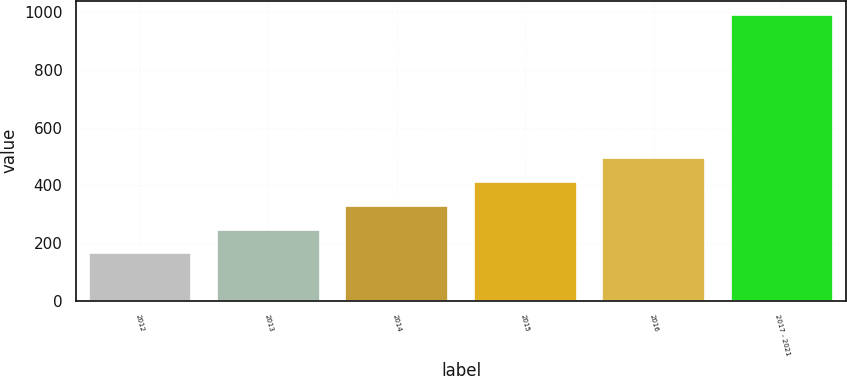<chart> <loc_0><loc_0><loc_500><loc_500><bar_chart><fcel>2012<fcel>2013<fcel>2014<fcel>2015<fcel>2016<fcel>2017 - 2021<nl><fcel>164<fcel>246.6<fcel>329.2<fcel>411.8<fcel>494.4<fcel>990<nl></chart> 